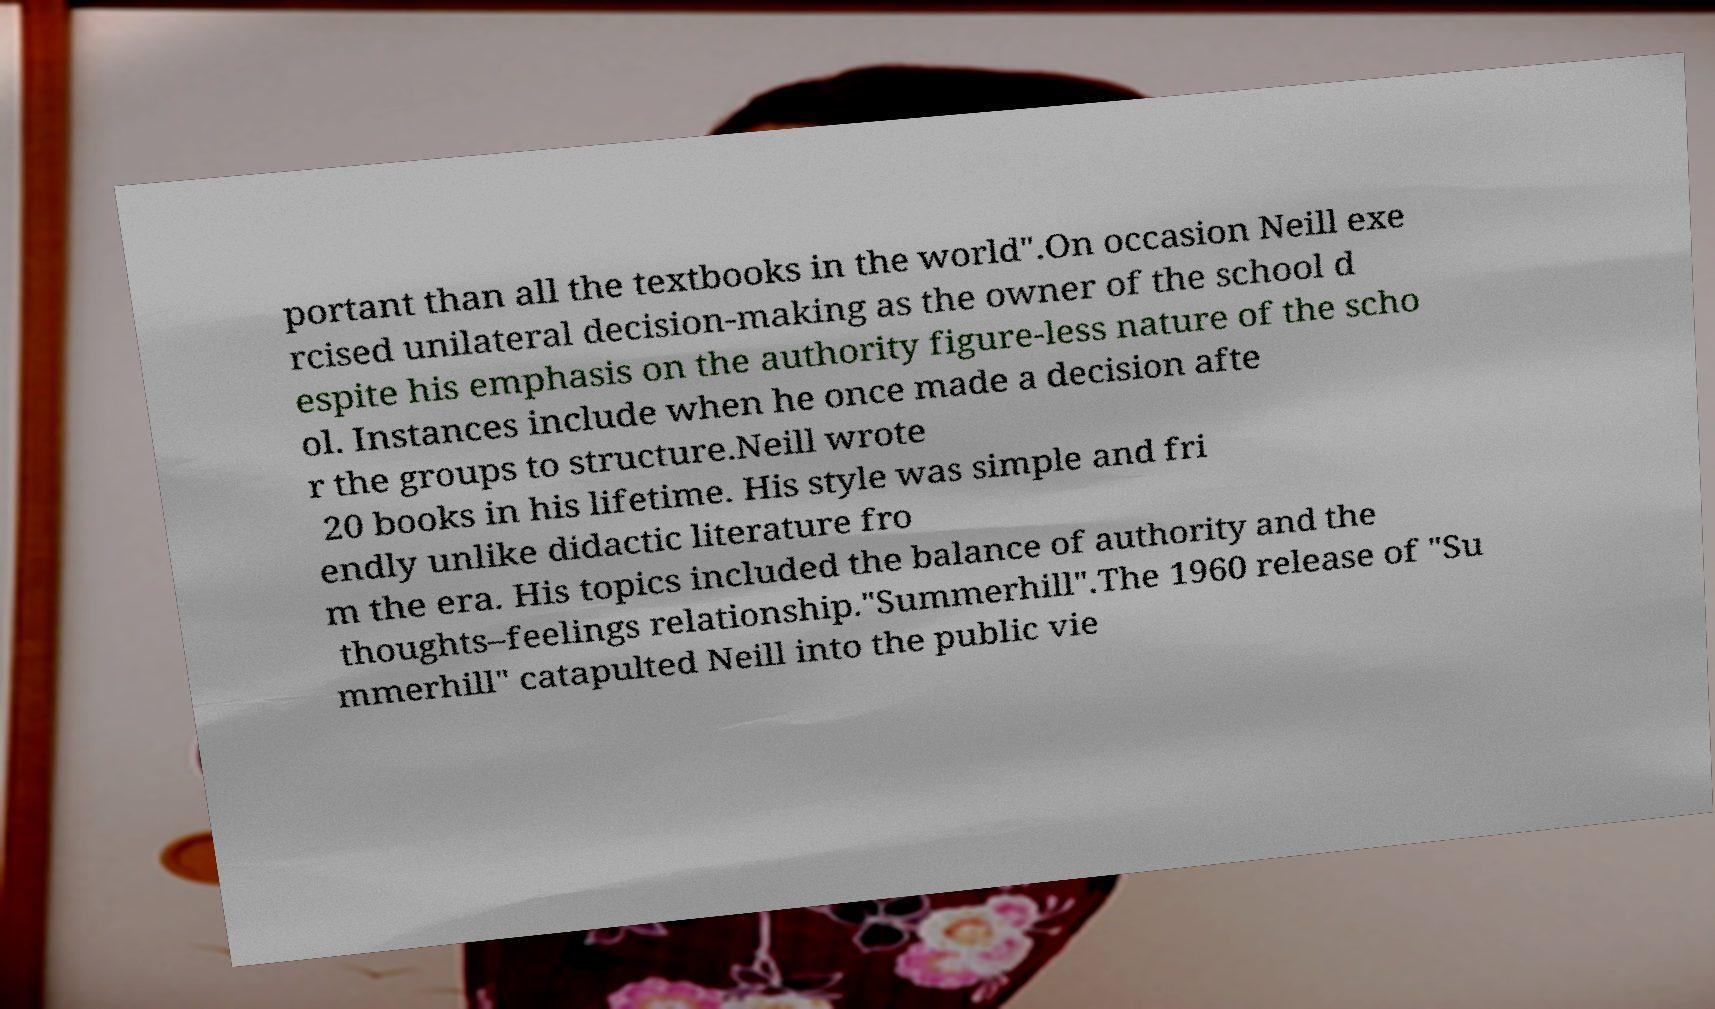Can you read and provide the text displayed in the image?This photo seems to have some interesting text. Can you extract and type it out for me? portant than all the textbooks in the world".On occasion Neill exe rcised unilateral decision-making as the owner of the school d espite his emphasis on the authority figure-less nature of the scho ol. Instances include when he once made a decision afte r the groups to structure.Neill wrote 20 books in his lifetime. His style was simple and fri endly unlike didactic literature fro m the era. His topics included the balance of authority and the thoughts–feelings relationship."Summerhill".The 1960 release of "Su mmerhill" catapulted Neill into the public vie 